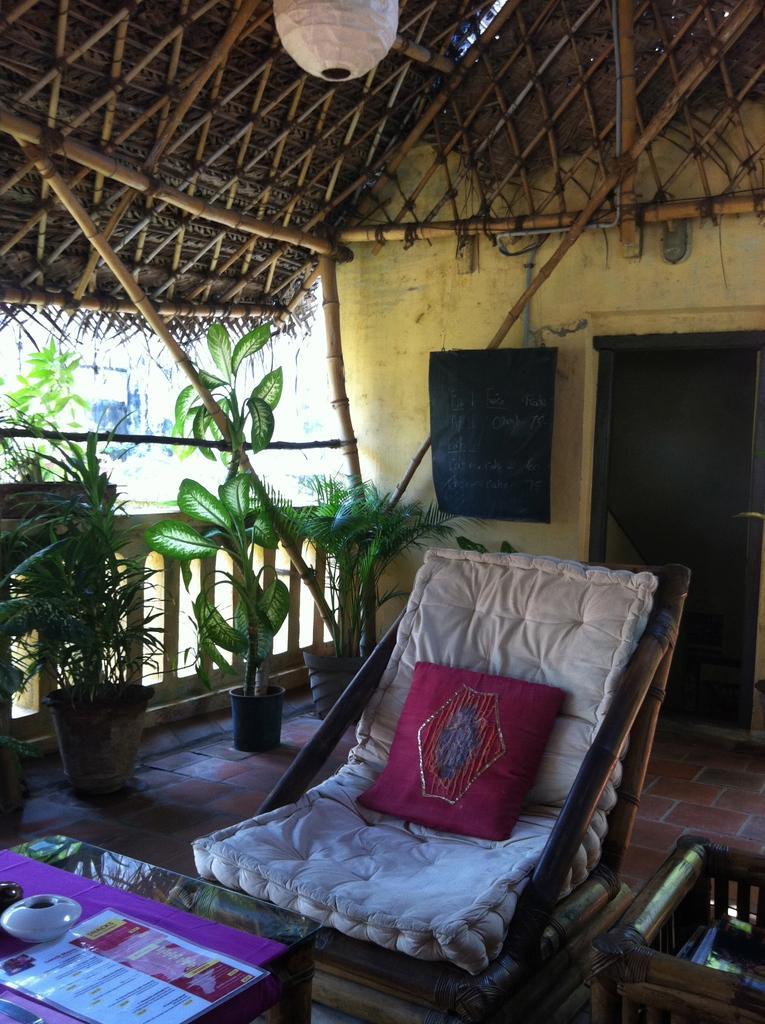In one or two sentences, can you explain what this image depicts? In the image we can see there is a chair on which there is a cushion and other side there are plants in a pot and on the wall there is a black board. 